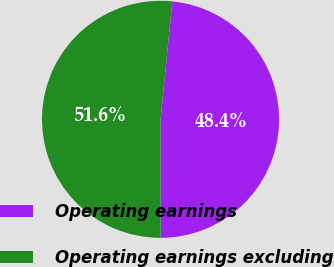<chart> <loc_0><loc_0><loc_500><loc_500><pie_chart><fcel>Operating earnings<fcel>Operating earnings excluding<nl><fcel>48.41%<fcel>51.59%<nl></chart> 